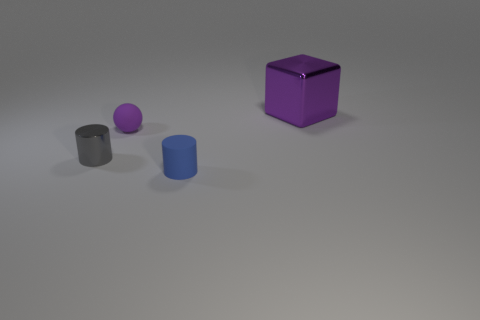There is a metallic cylinder that is the same size as the blue matte thing; what color is it?
Offer a terse response. Gray. How many other shiny things are the same shape as the gray thing?
Provide a succinct answer. 0. Does the shiny cylinder have the same size as the shiny cube behind the tiny shiny thing?
Offer a terse response. No. There is a tiny rubber object in front of the metallic object that is in front of the purple metal object; what is its shape?
Give a very brief answer. Cylinder. Is the number of tiny purple spheres that are on the right side of the big metal cube less than the number of small blue things?
Provide a succinct answer. Yes. What is the shape of the other object that is the same color as the big metallic object?
Give a very brief answer. Sphere. How many blue matte things are the same size as the cube?
Your answer should be compact. 0. What shape is the purple thing that is in front of the large metallic cube?
Your response must be concise. Sphere. Are there fewer blue cylinders than small brown spheres?
Your response must be concise. No. Is there anything else that has the same color as the large shiny object?
Offer a terse response. Yes. 